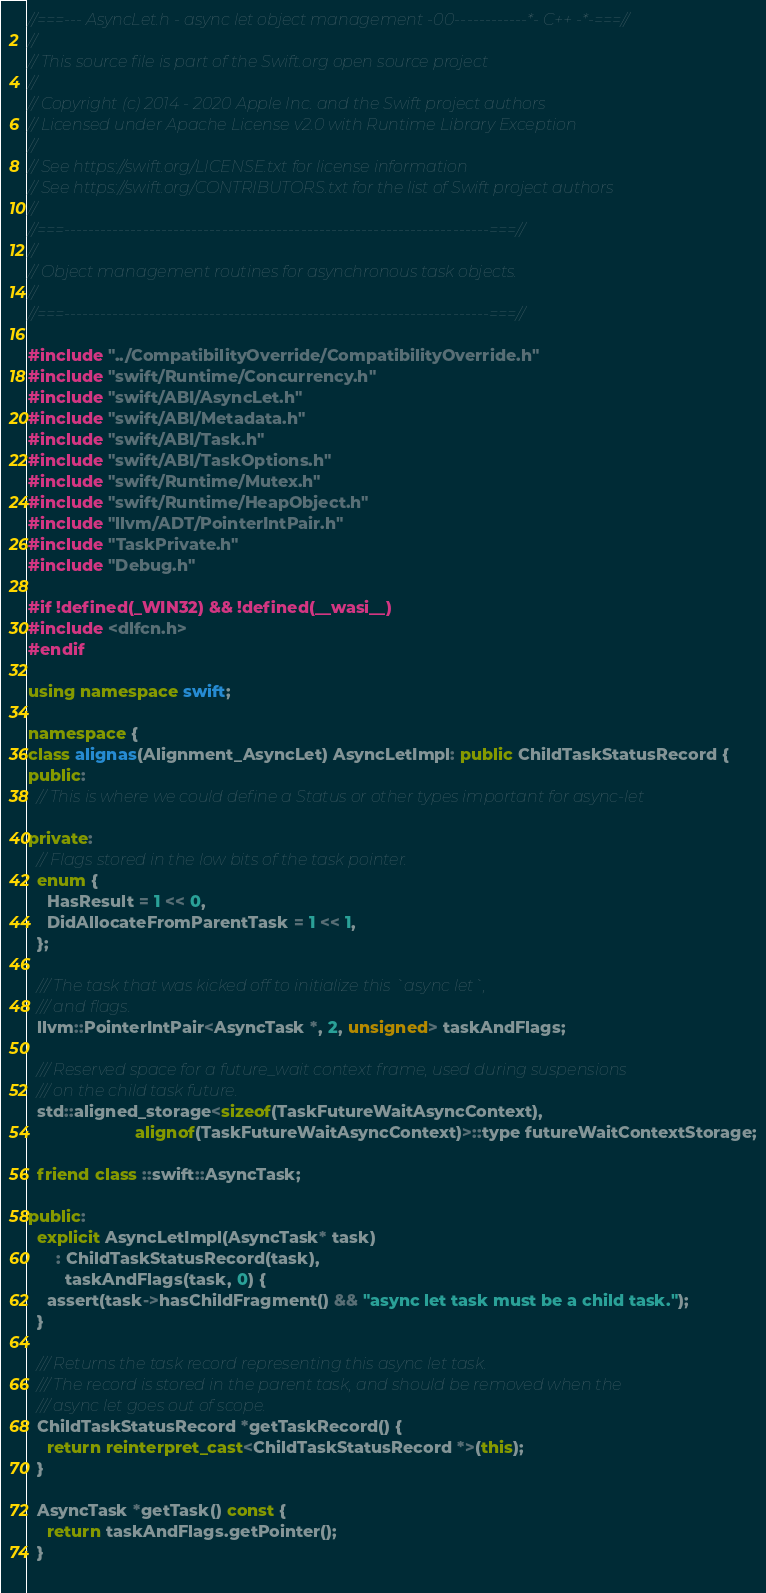<code> <loc_0><loc_0><loc_500><loc_500><_C++_>//===--- AsyncLet.h - async let object management -00------------*- C++ -*-===//
//
// This source file is part of the Swift.org open source project
//
// Copyright (c) 2014 - 2020 Apple Inc. and the Swift project authors
// Licensed under Apache License v2.0 with Runtime Library Exception
//
// See https://swift.org/LICENSE.txt for license information
// See https://swift.org/CONTRIBUTORS.txt for the list of Swift project authors
//
//===----------------------------------------------------------------------===//
//
// Object management routines for asynchronous task objects.
//
//===----------------------------------------------------------------------===//

#include "../CompatibilityOverride/CompatibilityOverride.h"
#include "swift/Runtime/Concurrency.h"
#include "swift/ABI/AsyncLet.h"
#include "swift/ABI/Metadata.h"
#include "swift/ABI/Task.h"
#include "swift/ABI/TaskOptions.h"
#include "swift/Runtime/Mutex.h"
#include "swift/Runtime/HeapObject.h"
#include "llvm/ADT/PointerIntPair.h"
#include "TaskPrivate.h"
#include "Debug.h"

#if !defined(_WIN32) && !defined(__wasi__)
#include <dlfcn.h>
#endif

using namespace swift;

namespace {
class alignas(Alignment_AsyncLet) AsyncLetImpl: public ChildTaskStatusRecord {
public:
  // This is where we could define a Status or other types important for async-let

private:
  // Flags stored in the low bits of the task pointer.
  enum {
    HasResult = 1 << 0,
    DidAllocateFromParentTask = 1 << 1,
  };
  
  /// The task that was kicked off to initialize this `async let`,
  /// and flags.
  llvm::PointerIntPair<AsyncTask *, 2, unsigned> taskAndFlags;
  
  /// Reserved space for a future_wait context frame, used during suspensions
  /// on the child task future.
  std::aligned_storage<sizeof(TaskFutureWaitAsyncContext),
                       alignof(TaskFutureWaitAsyncContext)>::type futureWaitContextStorage;
  
  friend class ::swift::AsyncTask;

public:
  explicit AsyncLetImpl(AsyncTask* task)
      : ChildTaskStatusRecord(task),
        taskAndFlags(task, 0) {
    assert(task->hasChildFragment() && "async let task must be a child task.");
  }

  /// Returns the task record representing this async let task.
  /// The record is stored in the parent task, and should be removed when the
  /// async let goes out of scope.
  ChildTaskStatusRecord *getTaskRecord() {
    return reinterpret_cast<ChildTaskStatusRecord *>(this);
  }

  AsyncTask *getTask() const {
    return taskAndFlags.getPointer();
  }
  </code> 